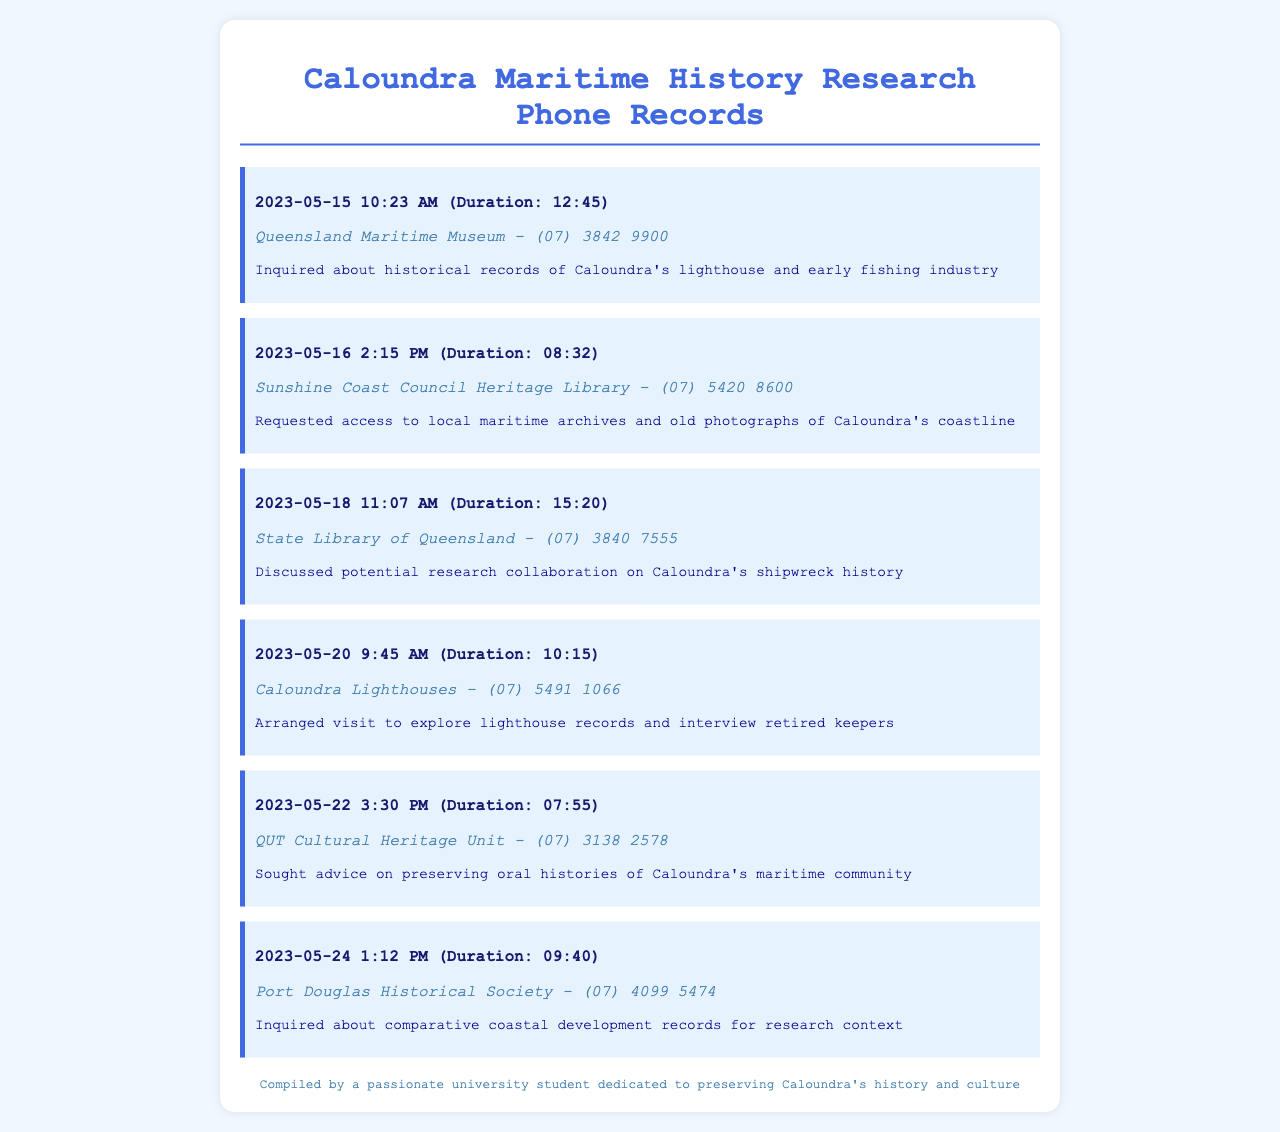What is the date of the call to Queensland Maritime Museum? The document lists the call to Queensland Maritime Museum on May 15, 2023.
Answer: May 15, 2023 What was the duration of the call to Sunshine Coast Council Heritage Library? The duration of the call is noted as 8 minutes and 32 seconds.
Answer: 08:32 What institution was contacted regarding Caloundra's shipwreck history? The State Library of Queensland was discussed for potential research collaboration on this topic.
Answer: State Library of Queensland What type of records were inquired about during the call to Caloundra Lighthouses? The inquiry was about exploring lighthouse records and interviewing retired keepers.
Answer: Lighthouse records How long was the call made to QUT Cultural Heritage Unit? The call's duration to QUT Cultural Heritage Unit is recorded as 7 minutes and 55 seconds.
Answer: 07:55 What was the purpose of the call to Port Douglas Historical Society? The purpose was to inquire about comparative coastal development records for research context.
Answer: Comparative coastal development records Which museum's phone number is (07) 3842 9900? The phone number belongs to the Queensland Maritime Museum.
Answer: Queensland Maritime Museum What inquiry was made during the call on May 22? The inquiry involved preserving oral histories of Caloundra's maritime community.
Answer: Preserving oral histories What was discussed during the call on May 18? The discussion focused on potential research collaboration about shipwreck history.
Answer: Research collaboration on shipwreck history 